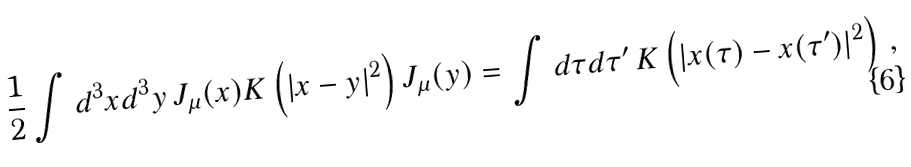Convert formula to latex. <formula><loc_0><loc_0><loc_500><loc_500>\frac { 1 } { 2 } \int d ^ { 3 } x d ^ { 3 } y \, J _ { \mu } ( x ) K \left ( | x - y | ^ { 2 } \right ) J _ { \mu } ( y ) = \int d \tau d \tau ^ { \prime } \, K \left ( | x ( \tau ) - x ( \tau ^ { \prime } ) | ^ { 2 } \right ) \, ,</formula> 